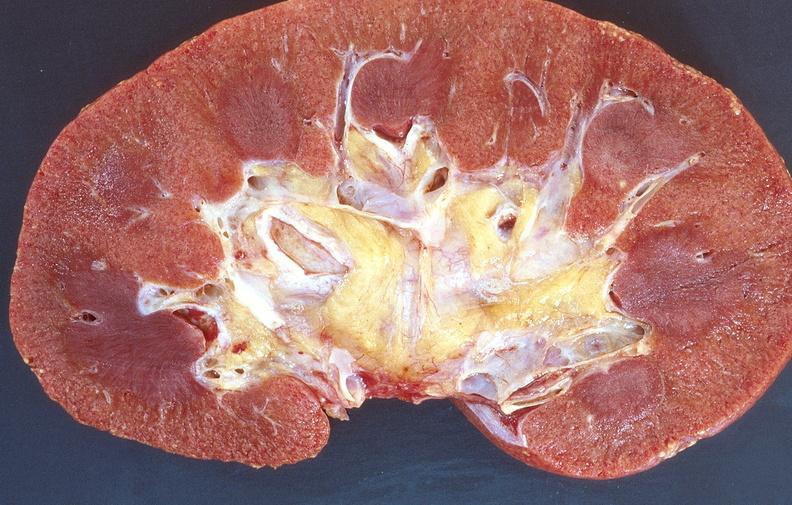where is this?
Answer the question using a single word or phrase. Urinary 